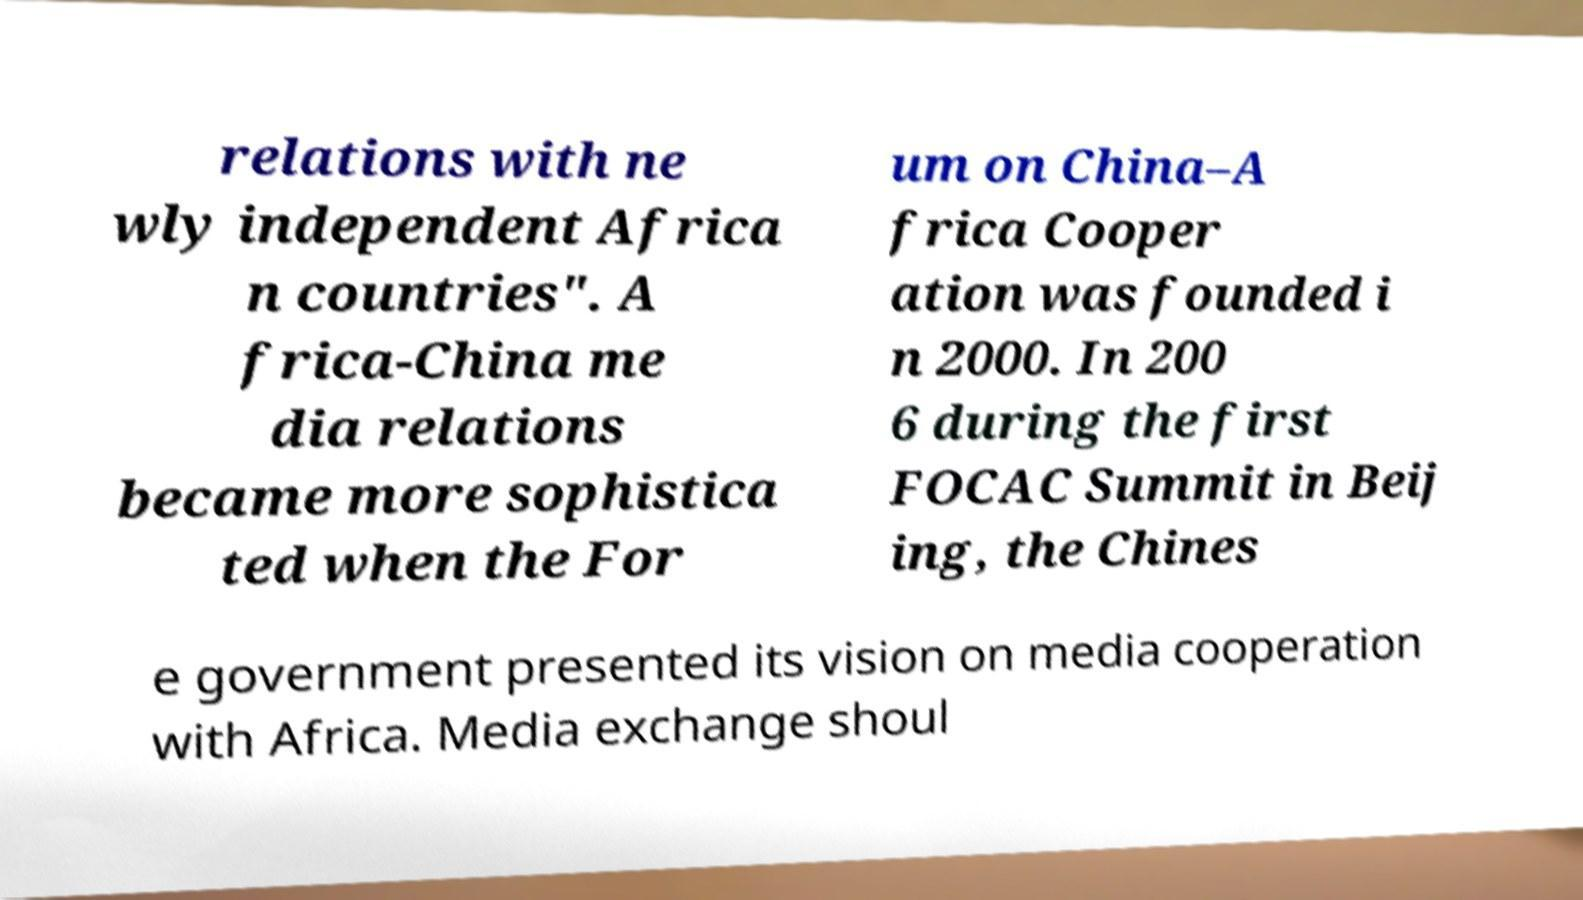For documentation purposes, I need the text within this image transcribed. Could you provide that? relations with ne wly independent Africa n countries". A frica-China me dia relations became more sophistica ted when the For um on China–A frica Cooper ation was founded i n 2000. In 200 6 during the first FOCAC Summit in Beij ing, the Chines e government presented its vision on media cooperation with Africa. Media exchange shoul 